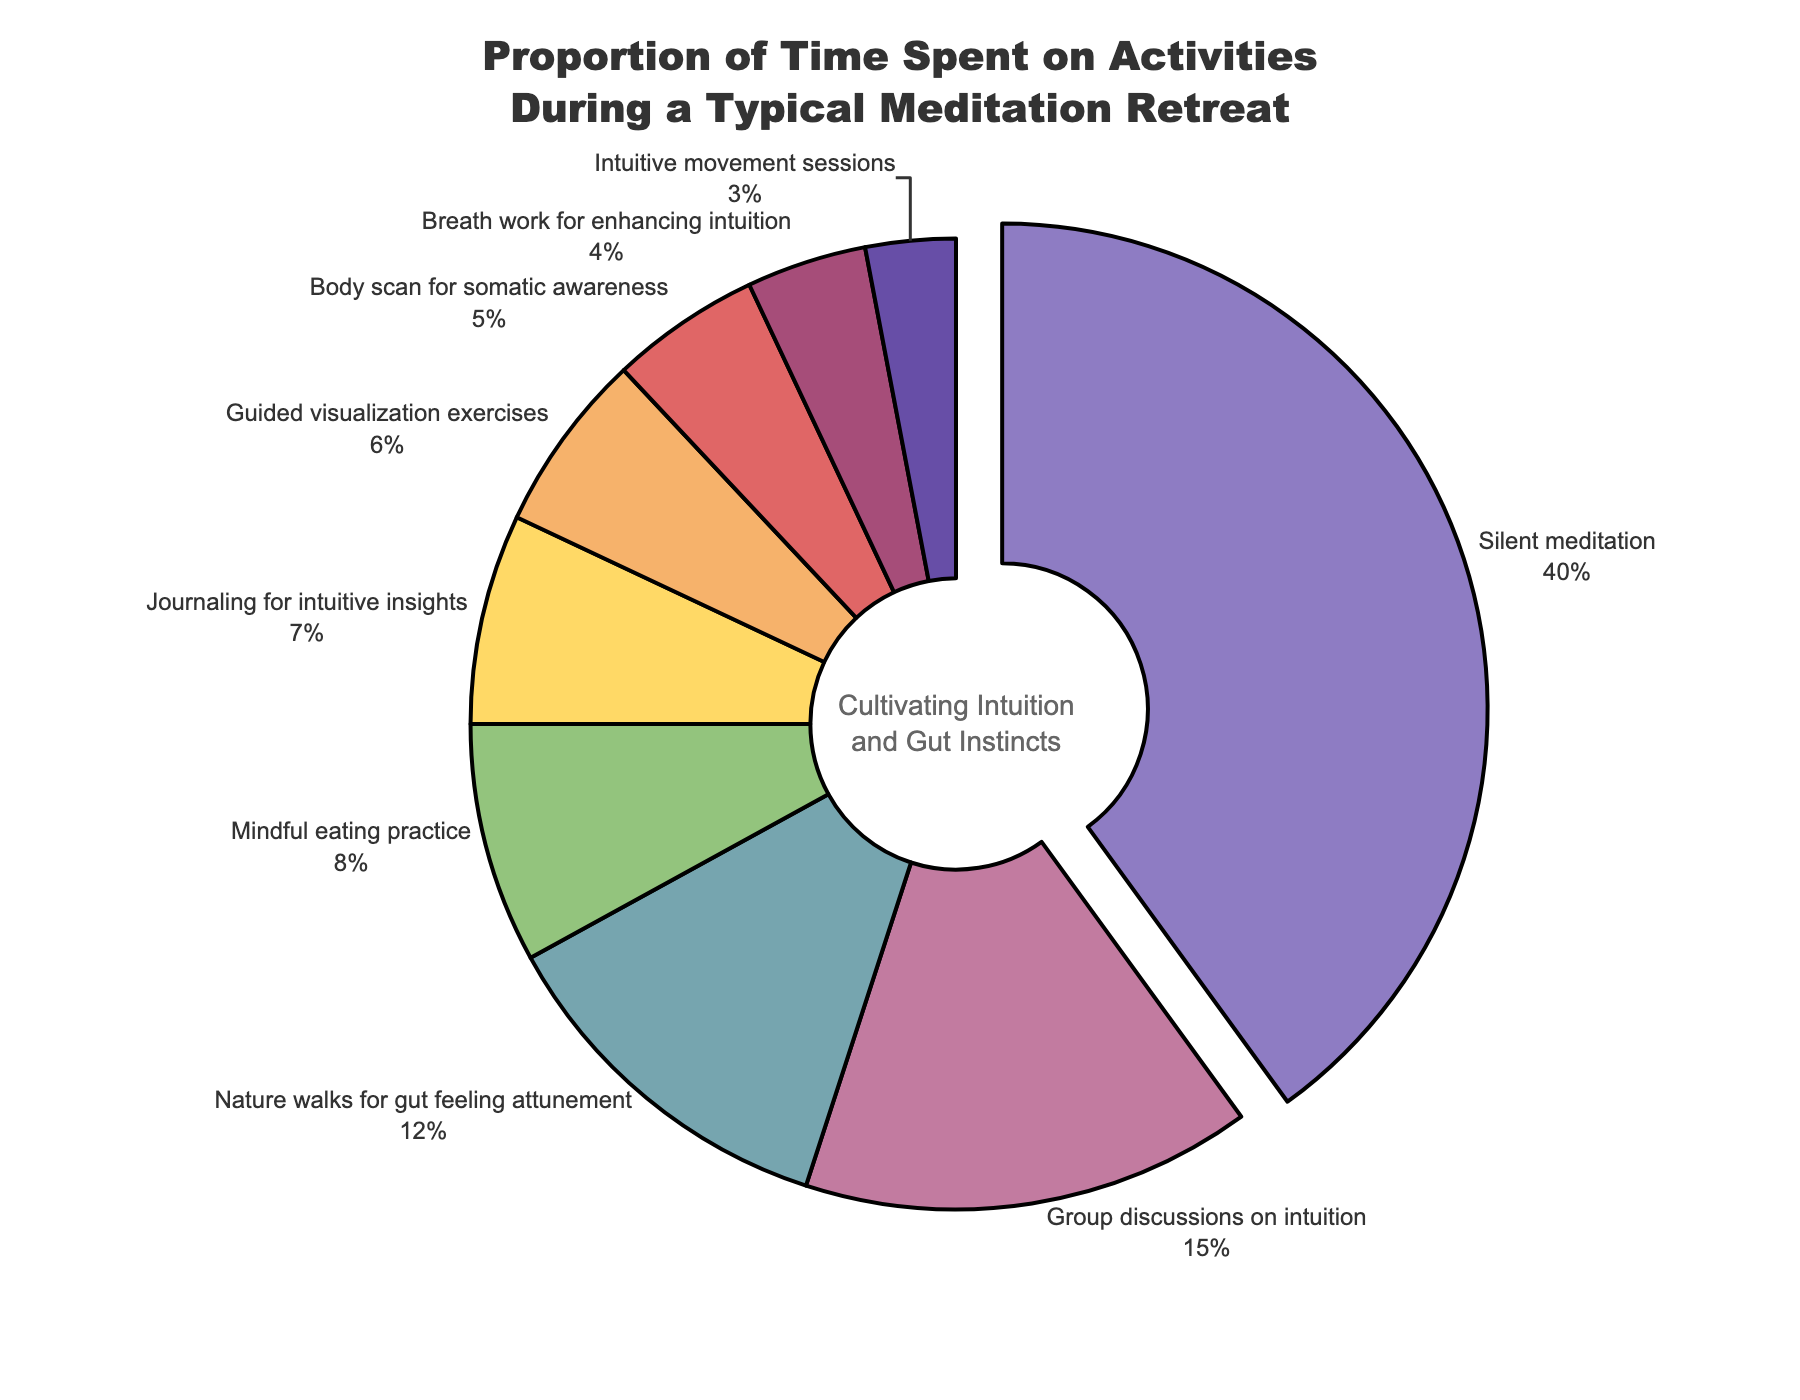What activity takes up the largest portion of time? The largest portion of time is represented by the biggest slice in the pie chart. The largest portion is "Silent meditation".
Answer: Silent meditation Which activity takes less time: "Guided visualization exercises" or "Breath work for enhancing intuition"? To determine which takes less time, we compare the percentages of each. "Guided visualization exercises" is 6% and "Breath work for enhancing intuition" is 4%.
Answer: Breath work for enhancing intuition What is the combined percentage of time spent on "Nature walks for gut feeling attunement" and "Mindful eating practice"? We add the percentages of "Nature walks for gut feeling attunement" (12%) and "Mindful eating practice" (8%). The combined percentage is 12 + 8 = 20%.
Answer: 20% Are "Journaling for intuitive insights" and "Body scan for somatic awareness" given more combined time than "Silent meditation"? "Journaling for intuitive insights" is 7% and "Body scan for somatic awareness" is 5%, so their combined time is 7 + 5 = 12%. Since "Silent meditation" is 40%, 12% is much less than 40%.
Answer: No Which activities each take up less than 5% of the time? Reviewing each slice that is less than 5%, we see "Breath work for enhancing intuition" (4%) and "Intuitive movement sessions" (3%).
Answer: Breath work for enhancing intuition, Intuitive movement sessions How much more time is spent on "Silent meditation" compared to "Group discussions on intuition"? "Silent meditation" occupies 40% of the time and "Group discussions on intuition" 15%. The difference is 40 - 15 = 25%.
Answer: 25% What is the sum of the percentages for all activities? To ensure the percentages add up to 100%, we sum 40 + 15 + 12 + 8 + 7 + 6 + 5 + 4 + 3 = 100%.
Answer: 100% Which activity uses a color at the very end of the rainbow sequence shown? The rainbow sequence finishes with dark purple, which corresponds to "Intuitive movement sessions".
Answer: Intuitive movement sessions 